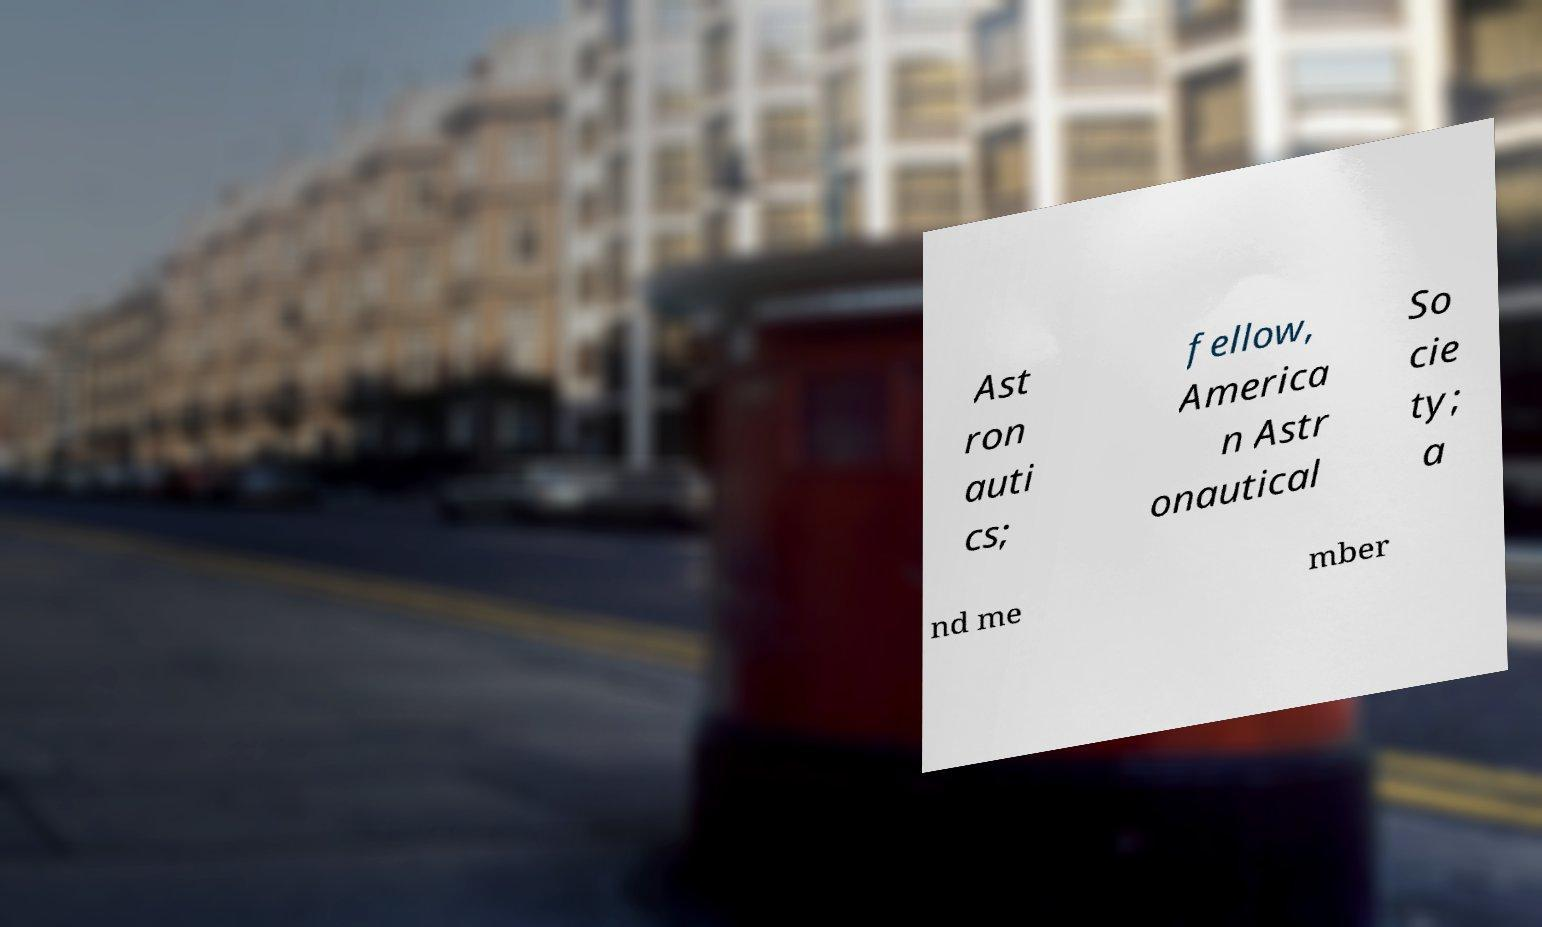For documentation purposes, I need the text within this image transcribed. Could you provide that? Ast ron auti cs; fellow, America n Astr onautical So cie ty; a nd me mber 